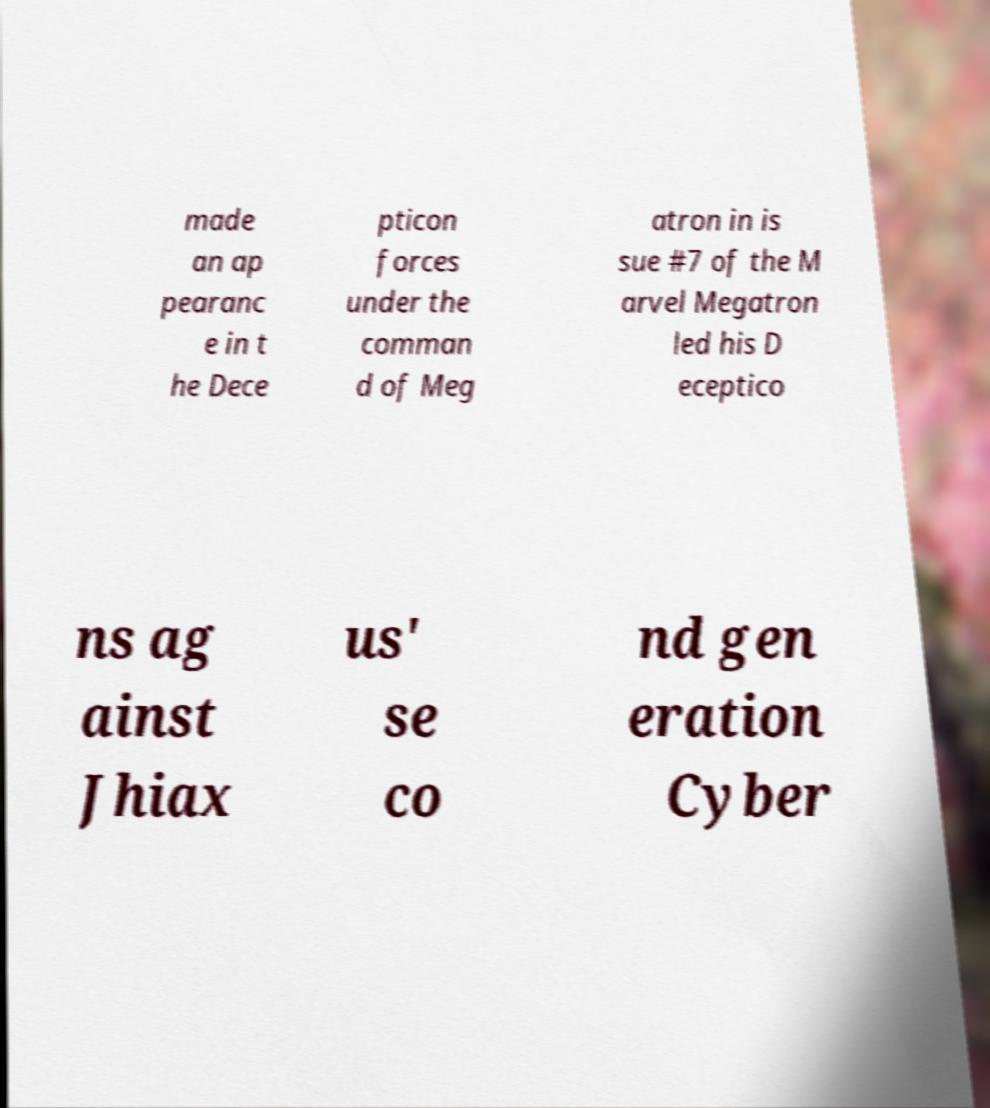Please read and relay the text visible in this image. What does it say? made an ap pearanc e in t he Dece pticon forces under the comman d of Meg atron in is sue #7 of the M arvel Megatron led his D eceptico ns ag ainst Jhiax us' se co nd gen eration Cyber 